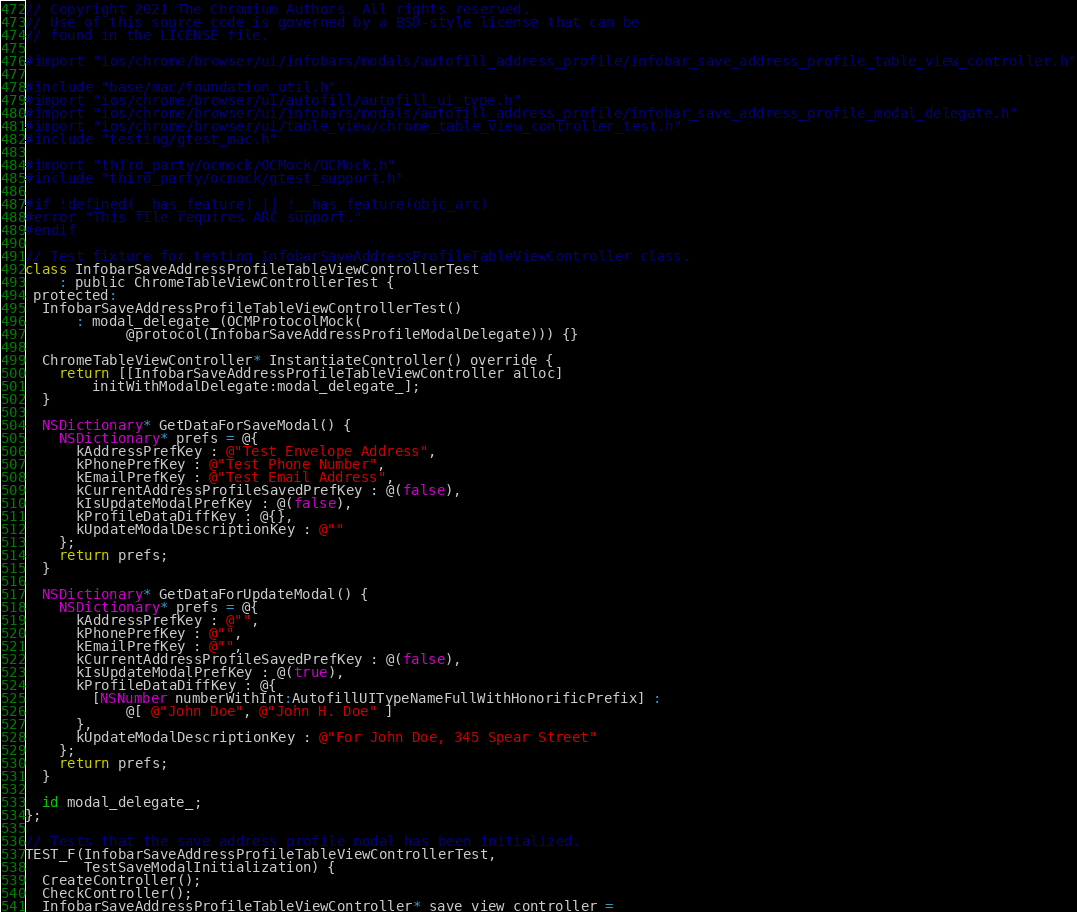<code> <loc_0><loc_0><loc_500><loc_500><_ObjectiveC_>// Copyright 2021 The Chromium Authors. All rights reserved.
// Use of this source code is governed by a BSD-style license that can be
// found in the LICENSE file.

#import "ios/chrome/browser/ui/infobars/modals/autofill_address_profile/infobar_save_address_profile_table_view_controller.h"

#include "base/mac/foundation_util.h"
#import "ios/chrome/browser/ui/autofill/autofill_ui_type.h"
#import "ios/chrome/browser/ui/infobars/modals/autofill_address_profile/infobar_save_address_profile_modal_delegate.h"
#import "ios/chrome/browser/ui/table_view/chrome_table_view_controller_test.h"
#include "testing/gtest_mac.h"

#import "third_party/ocmock/OCMock/OCMock.h"
#include "third_party/ocmock/gtest_support.h"

#if !defined(__has_feature) || !__has_feature(objc_arc)
#error "This file requires ARC support."
#endif

// Test fixture for testing InfobarSaveAddressProfileTableViewController class.
class InfobarSaveAddressProfileTableViewControllerTest
    : public ChromeTableViewControllerTest {
 protected:
  InfobarSaveAddressProfileTableViewControllerTest()
      : modal_delegate_(OCMProtocolMock(
            @protocol(InfobarSaveAddressProfileModalDelegate))) {}

  ChromeTableViewController* InstantiateController() override {
    return [[InfobarSaveAddressProfileTableViewController alloc]
        initWithModalDelegate:modal_delegate_];
  }

  NSDictionary* GetDataForSaveModal() {
    NSDictionary* prefs = @{
      kAddressPrefKey : @"Test Envelope Address",
      kPhonePrefKey : @"Test Phone Number",
      kEmailPrefKey : @"Test Email Address",
      kCurrentAddressProfileSavedPrefKey : @(false),
      kIsUpdateModalPrefKey : @(false),
      kProfileDataDiffKey : @{},
      kUpdateModalDescriptionKey : @""
    };
    return prefs;
  }

  NSDictionary* GetDataForUpdateModal() {
    NSDictionary* prefs = @{
      kAddressPrefKey : @"",
      kPhonePrefKey : @"",
      kEmailPrefKey : @"",
      kCurrentAddressProfileSavedPrefKey : @(false),
      kIsUpdateModalPrefKey : @(true),
      kProfileDataDiffKey : @{
        [NSNumber numberWithInt:AutofillUITypeNameFullWithHonorificPrefix] :
            @[ @"John Doe", @"John H. Doe" ]
      },
      kUpdateModalDescriptionKey : @"For John Doe, 345 Spear Street"
    };
    return prefs;
  }

  id modal_delegate_;
};

// Tests that the save address profile modal has been initialized.
TEST_F(InfobarSaveAddressProfileTableViewControllerTest,
       TestSaveModalInitialization) {
  CreateController();
  CheckController();
  InfobarSaveAddressProfileTableViewController* save_view_controller =</code> 